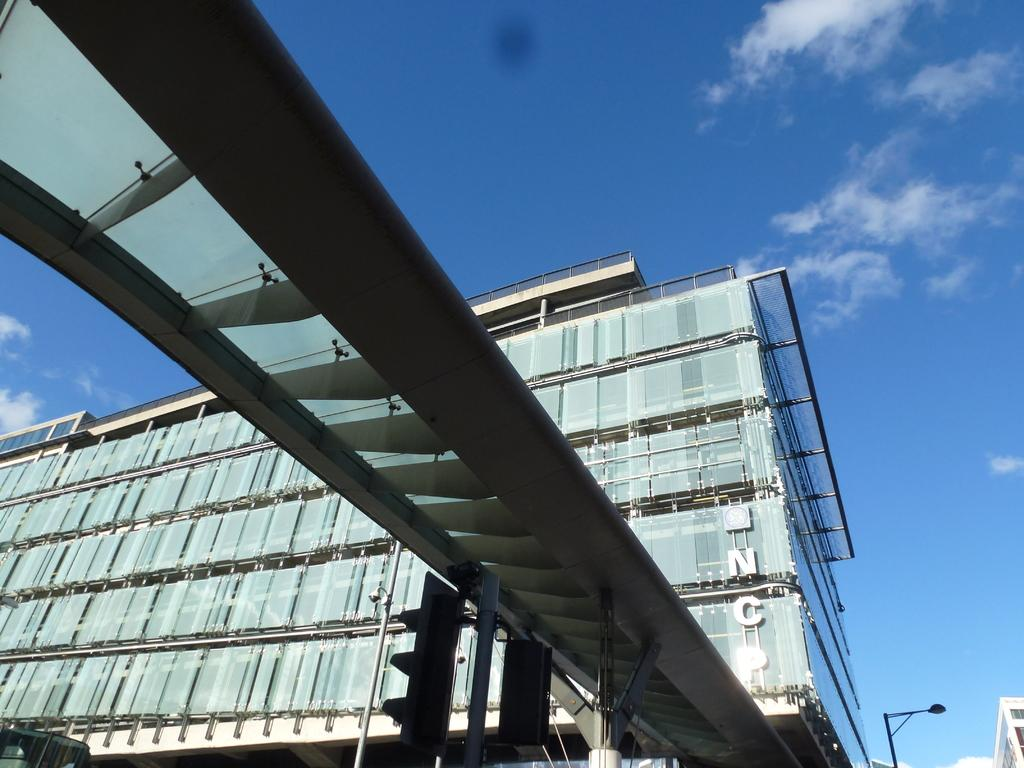What is the main subject in the center of the image? There is a building in the center of the image. What else can be seen in the center of the image? There are traffic signals in the center of the image. What is visible in the background of the image? The sky is visible in the background of the image. What type of weather can be inferred from the background of the image? Clouds are present in the background of the image, suggesting a partly cloudy day. What type of suit is hanging on the building in the image? There is no suit present in the image; it features a building and traffic signals. What is the zinc content of the clouds in the image? There is no zinc content to be determined in the image, as clouds are made of water droplets and ice crystals. 